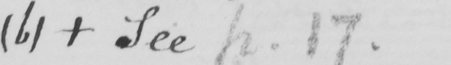Transcribe the text shown in this historical manuscript line. ( b )   +  See p.17 